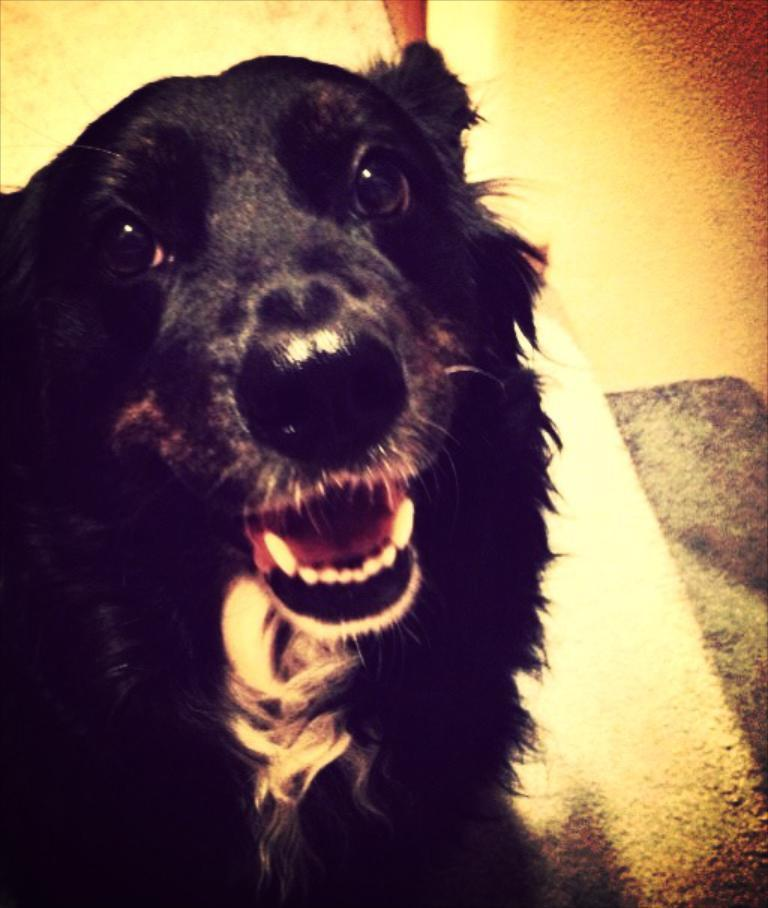What animal is present in the image? There is a dog in the image. Where is the dog located in the image? The dog is in the middle of the image. What color is the dog? The dog is black in color. What type of sweater is the dog wearing in the image? There is no sweater present in the image; the dog is not wearing any clothing. 